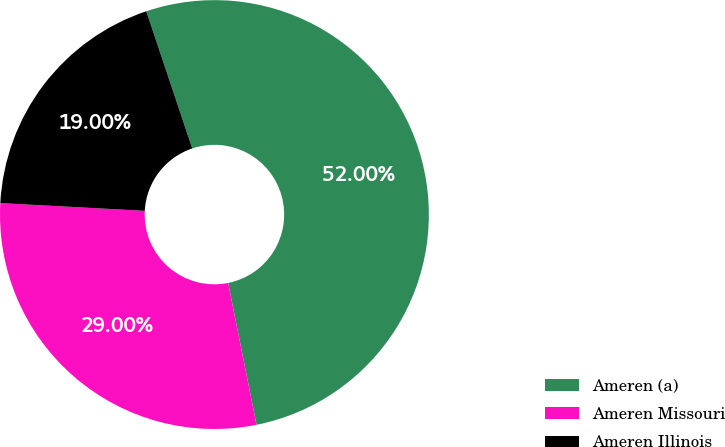<chart> <loc_0><loc_0><loc_500><loc_500><pie_chart><fcel>Ameren (a)<fcel>Ameren Missouri<fcel>Ameren Illinois<nl><fcel>52.0%<fcel>29.0%<fcel>19.0%<nl></chart> 